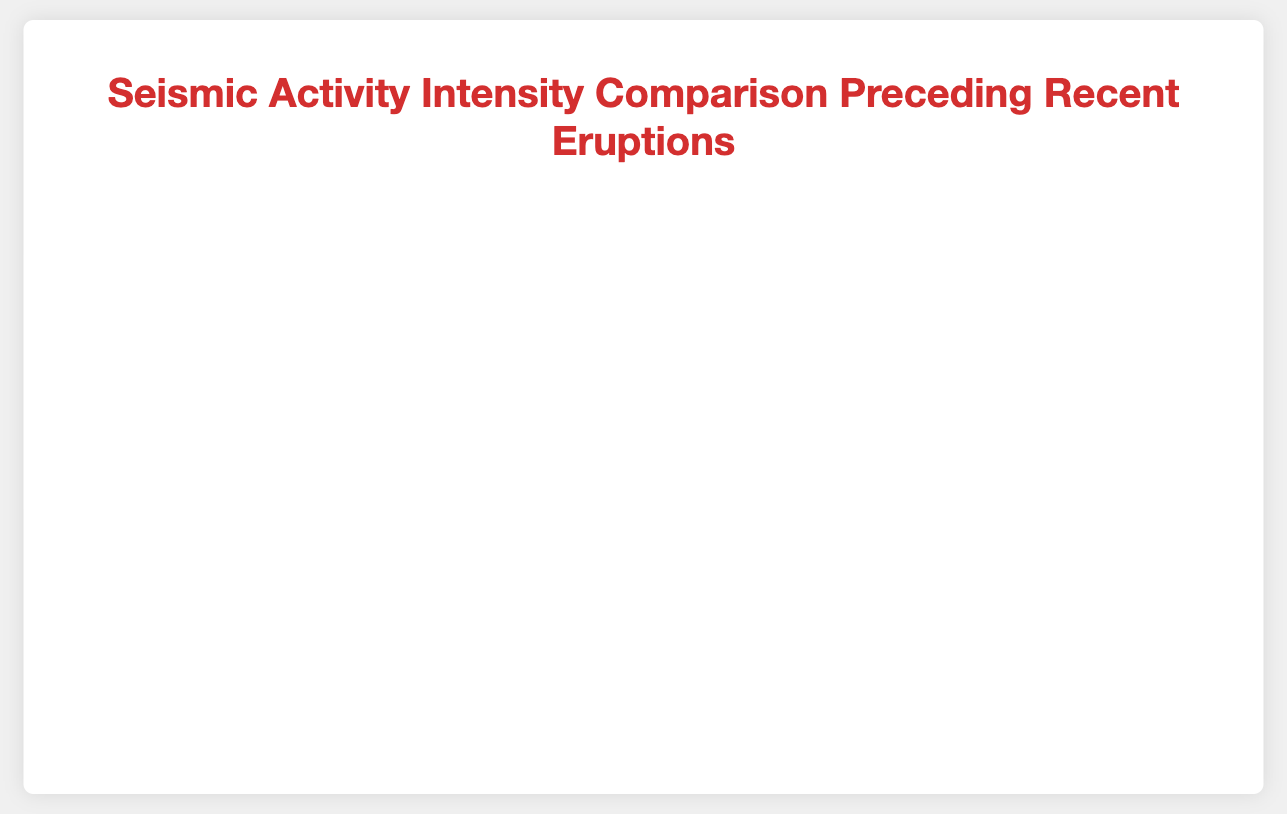Which volcano showed the highest seismic activity on the day of its eruption? By observing the plot, we can see the highest point for each volcano and compare them to identify the highest magnitude on the eruption day. Mount St. Helens and Mount Merapi both reached a magnitude of 4.5 on their eruption days.
Answer: Mount St. Helens and Mount Merapi What is the time interval between the first recorded seismic activity and the eruption date for Kīlauea? From the data points on the chart, Kīlauea's seismic activity starts on 2021-12-20, and the eruption date is 2022-01-03. Counting the days between these dates gives us the interval.
Answer: 14 days Which volcano had the most significant increase in seismic activity in the week before the eruption? To identify this, compare the magnitude increase in the last week for each volcano before the eruption date. By identifying the trends, Mount St. Helens showed the steepest increase from 3.9 to 4.5.
Answer: Mount St. Helens Compare the seismic activity trends of Mount Etna and Mount Merapi in the ten days leading up to the eruption. Examine the slope and trend of the lines representing these volcanoes over the last ten days before their eruptions. Both curves show increasing trends, but Mount Merapi's trend is steeper than Mount Etna's.
Answer: Mount Merapi has a steeper increase What was the average seismic magnitude during the last five days before the eruption for Mount St. Helens? Look at the magnitude values for the last five days before the eruption of Mount St. Helens and average them: (3.5 + 3.9 + 4.1 + 4.5) / 4.
Answer: 4 Which two volcanoes had the closest seismic activity levels five days before their eruptions? By comparing the magnitudes five days prior to eruption for each volcano, it appears Mount St. Helens had 3.5, Kīlauea had 3.7, Mount Etna had 3.4, and Mount Merapi had 3.7. Kīlauea and Mount Merapi are closest with 3.7 each.
Answer: Kīlauea and Mount Merapi How does the seismic activity of Kīlauea on its eruption day compare to that of Mount Etna? Compare the plotted values for Kīlauea and Mount Etna on their respective eruption days; Kīlauea has a magnitude of 4.2, and Mount Etna has 4.0.
Answer: Kīlauea had higher activity What is the overall trend in seismic activity for all volcanoes in the week leading up to eruption? By examining the slopes of all lines in the week before eruption, it's clear that each volcano shows a general increasing trend in seismic activity as they approach their eruption dates.
Answer: Increasing trend Identify the volcanoes whose seismic activity exceeded a magnitude of 4 before the eruption. By looking at data points that surpass a magnitude of 4 before the eruption date for each volcano, we see that Mount St. Helens, Kīlauea, and Mount Merapi had magnitudes exceeding 4.
Answer: Mount St. Helens, Kīlauea, and Mount Merapi 